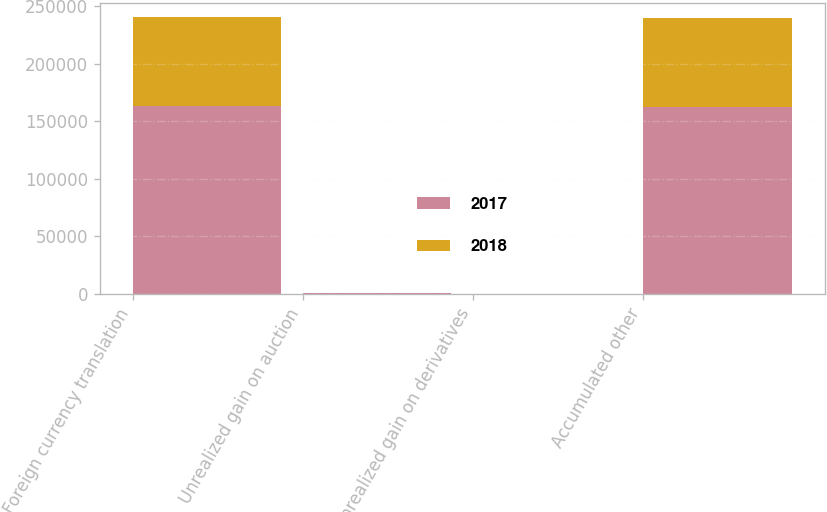Convert chart. <chart><loc_0><loc_0><loc_500><loc_500><stacked_bar_chart><ecel><fcel>Foreign currency translation<fcel>Unrealized gain on auction<fcel>Unrealized gain on derivatives<fcel>Accumulated other<nl><fcel>2017<fcel>163155<fcel>232<fcel>27<fcel>162896<nl><fcel>2018<fcel>77578<fcel>232<fcel>2<fcel>77344<nl></chart> 